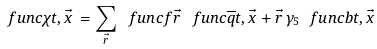Convert formula to latex. <formula><loc_0><loc_0><loc_500><loc_500>\ f u n c { \chi } { t , \vec { x } \, } = \sum _ { \vec { r } } \ f u n c { f } { \vec { r } \, } \ f u n c { \overline { q } } { t , \vec { x } + \vec { r } \, } \gamma _ { 5 } \ f u n c { b } { t , \vec { x } \, }</formula> 